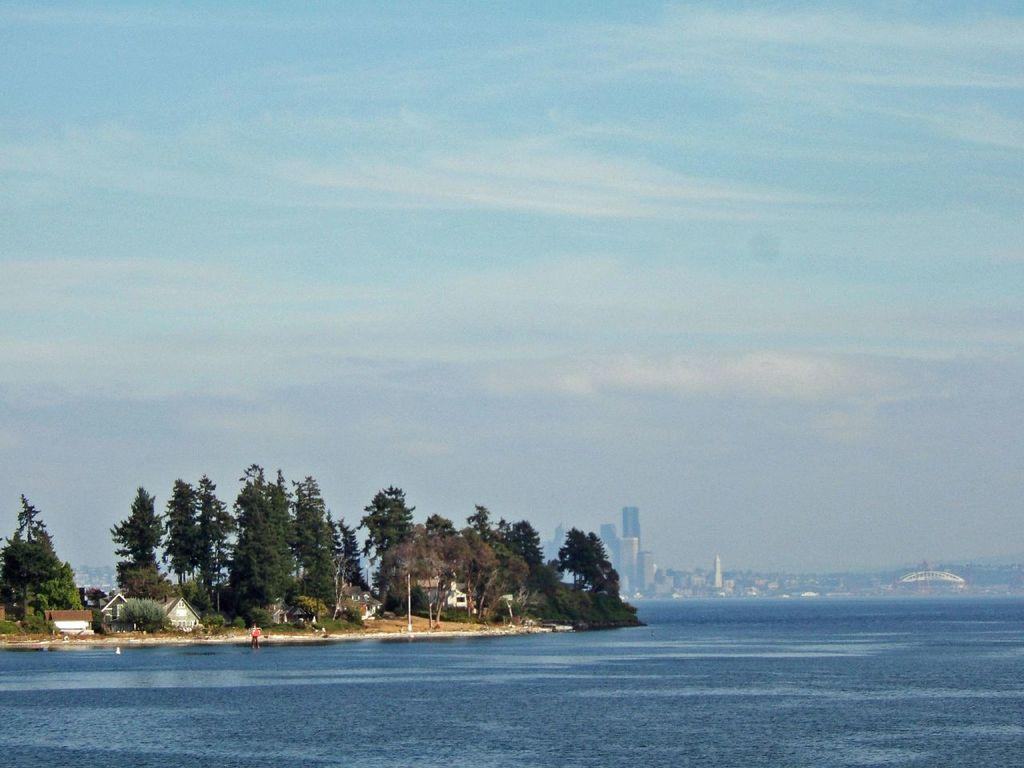What type of natural elements can be seen in the image? There are trees in the image. What type of man-made structures are present in the image? There are buildings in the image. Can you identify any living beings in the image? Yes, there appears to be a human in the image. How would you describe the sky in the image? The sky is blue and cloudy in the image. What type of feast is being prepared in the image? There is no indication of a feast being prepared in the image. What color is the copper bird in the image? There is no copper bird present in the image. 